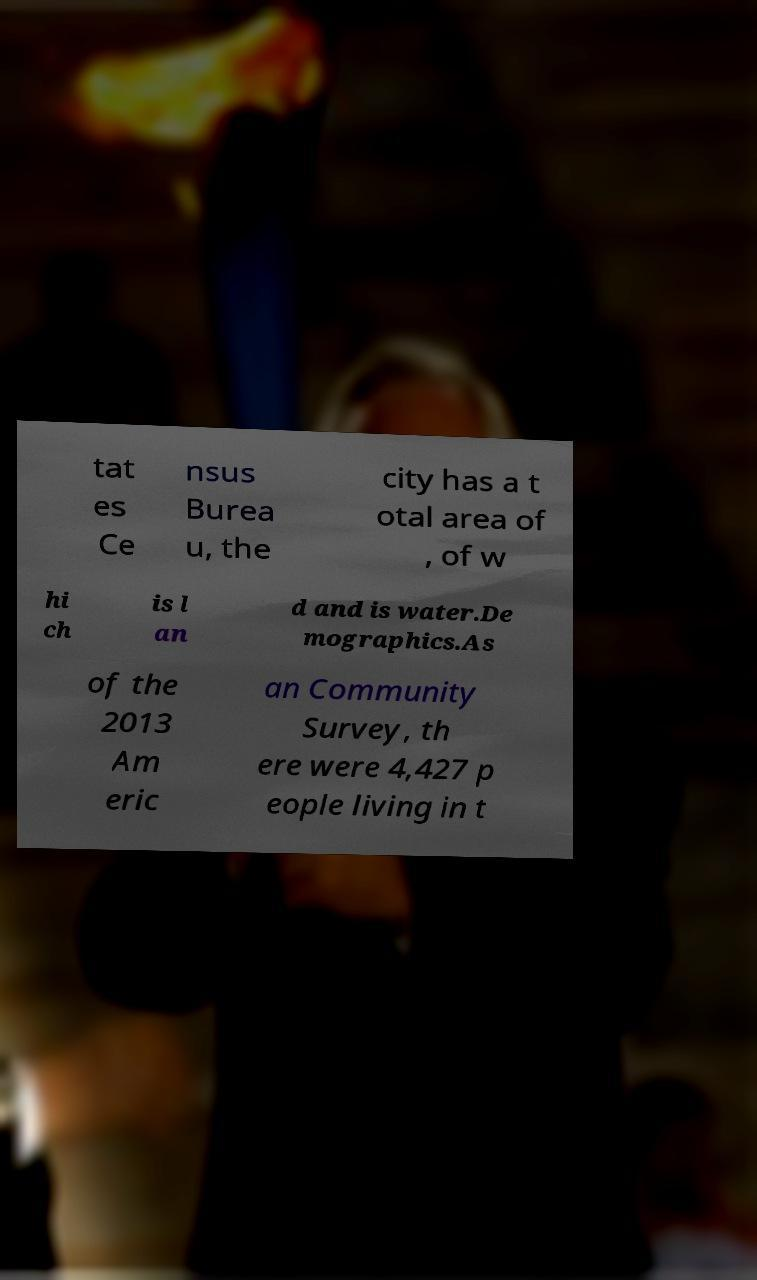Could you assist in decoding the text presented in this image and type it out clearly? tat es Ce nsus Burea u, the city has a t otal area of , of w hi ch is l an d and is water.De mographics.As of the 2013 Am eric an Community Survey, th ere were 4,427 p eople living in t 